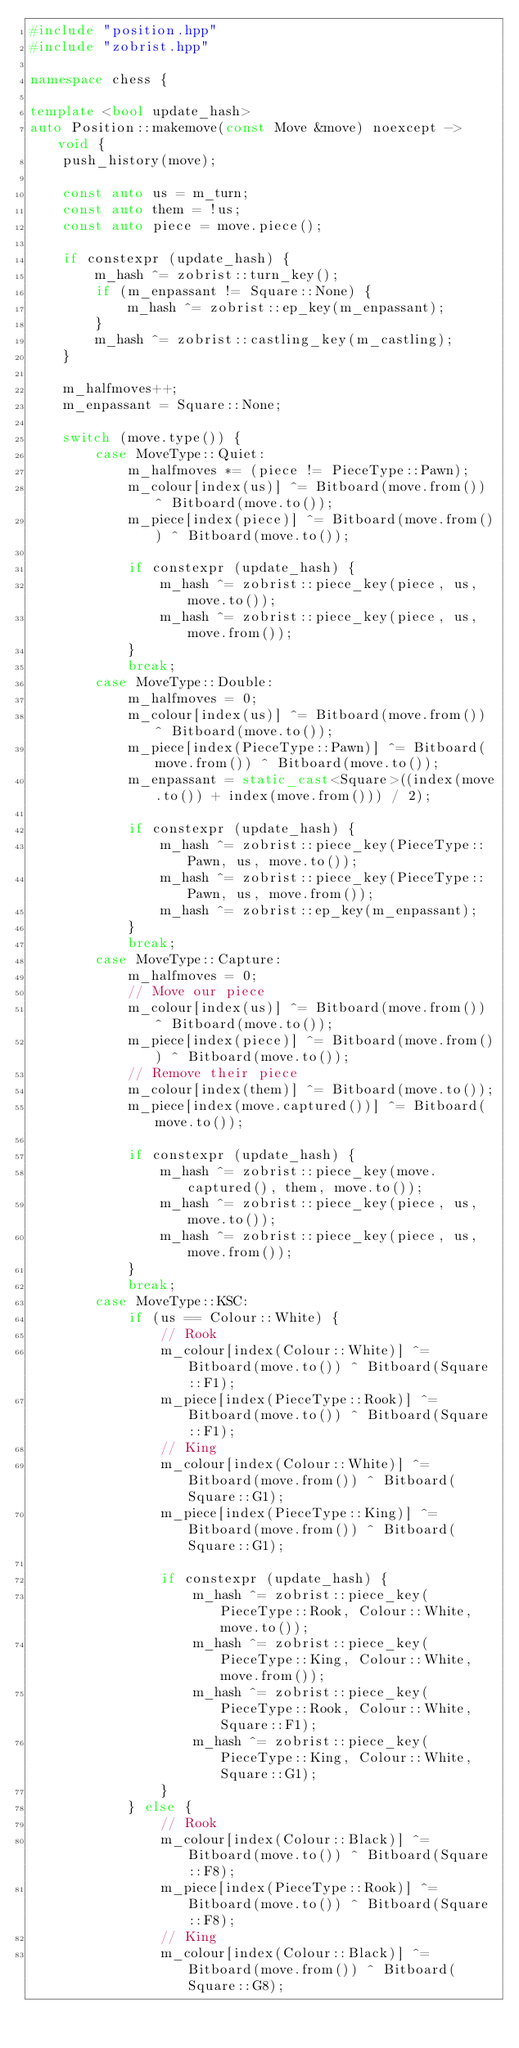<code> <loc_0><loc_0><loc_500><loc_500><_C++_>#include "position.hpp"
#include "zobrist.hpp"

namespace chess {

template <bool update_hash>
auto Position::makemove(const Move &move) noexcept -> void {
    push_history(move);

    const auto us = m_turn;
    const auto them = !us;
    const auto piece = move.piece();

    if constexpr (update_hash) {
        m_hash ^= zobrist::turn_key();
        if (m_enpassant != Square::None) {
            m_hash ^= zobrist::ep_key(m_enpassant);
        }
        m_hash ^= zobrist::castling_key(m_castling);
    }

    m_halfmoves++;
    m_enpassant = Square::None;

    switch (move.type()) {
        case MoveType::Quiet:
            m_halfmoves *= (piece != PieceType::Pawn);
            m_colour[index(us)] ^= Bitboard(move.from()) ^ Bitboard(move.to());
            m_piece[index(piece)] ^= Bitboard(move.from()) ^ Bitboard(move.to());

            if constexpr (update_hash) {
                m_hash ^= zobrist::piece_key(piece, us, move.to());
                m_hash ^= zobrist::piece_key(piece, us, move.from());
            }
            break;
        case MoveType::Double:
            m_halfmoves = 0;
            m_colour[index(us)] ^= Bitboard(move.from()) ^ Bitboard(move.to());
            m_piece[index(PieceType::Pawn)] ^= Bitboard(move.from()) ^ Bitboard(move.to());
            m_enpassant = static_cast<Square>((index(move.to()) + index(move.from())) / 2);

            if constexpr (update_hash) {
                m_hash ^= zobrist::piece_key(PieceType::Pawn, us, move.to());
                m_hash ^= zobrist::piece_key(PieceType::Pawn, us, move.from());
                m_hash ^= zobrist::ep_key(m_enpassant);
            }
            break;
        case MoveType::Capture:
            m_halfmoves = 0;
            // Move our piece
            m_colour[index(us)] ^= Bitboard(move.from()) ^ Bitboard(move.to());
            m_piece[index(piece)] ^= Bitboard(move.from()) ^ Bitboard(move.to());
            // Remove their piece
            m_colour[index(them)] ^= Bitboard(move.to());
            m_piece[index(move.captured())] ^= Bitboard(move.to());

            if constexpr (update_hash) {
                m_hash ^= zobrist::piece_key(move.captured(), them, move.to());
                m_hash ^= zobrist::piece_key(piece, us, move.to());
                m_hash ^= zobrist::piece_key(piece, us, move.from());
            }
            break;
        case MoveType::KSC:
            if (us == Colour::White) {
                // Rook
                m_colour[index(Colour::White)] ^= Bitboard(move.to()) ^ Bitboard(Square::F1);
                m_piece[index(PieceType::Rook)] ^= Bitboard(move.to()) ^ Bitboard(Square::F1);
                // King
                m_colour[index(Colour::White)] ^= Bitboard(move.from()) ^ Bitboard(Square::G1);
                m_piece[index(PieceType::King)] ^= Bitboard(move.from()) ^ Bitboard(Square::G1);

                if constexpr (update_hash) {
                    m_hash ^= zobrist::piece_key(PieceType::Rook, Colour::White, move.to());
                    m_hash ^= zobrist::piece_key(PieceType::King, Colour::White, move.from());
                    m_hash ^= zobrist::piece_key(PieceType::Rook, Colour::White, Square::F1);
                    m_hash ^= zobrist::piece_key(PieceType::King, Colour::White, Square::G1);
                }
            } else {
                // Rook
                m_colour[index(Colour::Black)] ^= Bitboard(move.to()) ^ Bitboard(Square::F8);
                m_piece[index(PieceType::Rook)] ^= Bitboard(move.to()) ^ Bitboard(Square::F8);
                // King
                m_colour[index(Colour::Black)] ^= Bitboard(move.from()) ^ Bitboard(Square::G8);</code> 